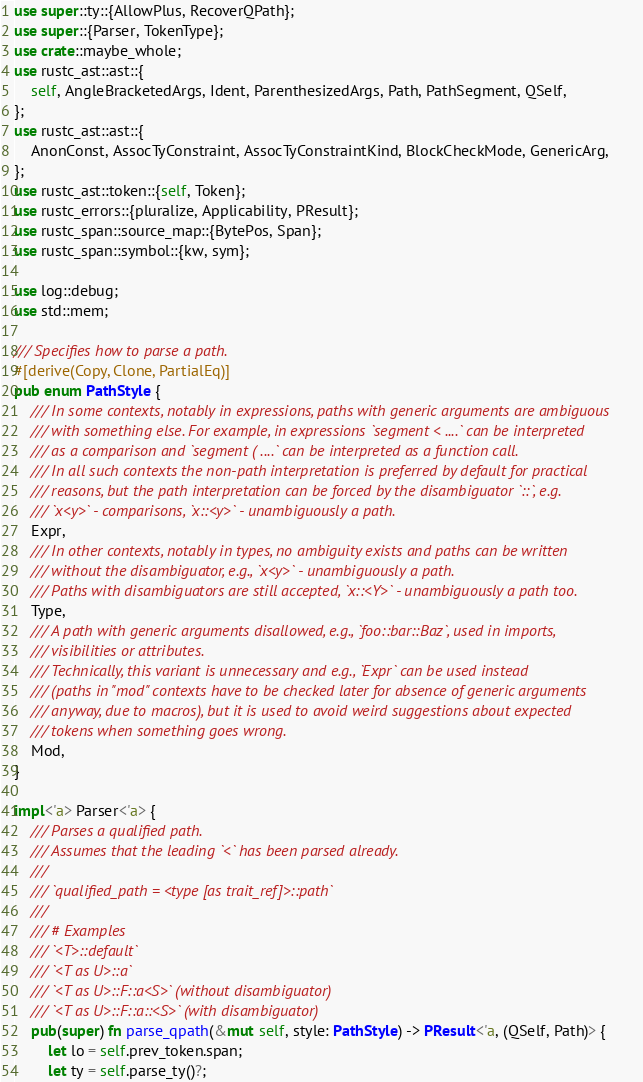<code> <loc_0><loc_0><loc_500><loc_500><_Rust_>use super::ty::{AllowPlus, RecoverQPath};
use super::{Parser, TokenType};
use crate::maybe_whole;
use rustc_ast::ast::{
    self, AngleBracketedArgs, Ident, ParenthesizedArgs, Path, PathSegment, QSelf,
};
use rustc_ast::ast::{
    AnonConst, AssocTyConstraint, AssocTyConstraintKind, BlockCheckMode, GenericArg,
};
use rustc_ast::token::{self, Token};
use rustc_errors::{pluralize, Applicability, PResult};
use rustc_span::source_map::{BytePos, Span};
use rustc_span::symbol::{kw, sym};

use log::debug;
use std::mem;

/// Specifies how to parse a path.
#[derive(Copy, Clone, PartialEq)]
pub enum PathStyle {
    /// In some contexts, notably in expressions, paths with generic arguments are ambiguous
    /// with something else. For example, in expressions `segment < ....` can be interpreted
    /// as a comparison and `segment ( ....` can be interpreted as a function call.
    /// In all such contexts the non-path interpretation is preferred by default for practical
    /// reasons, but the path interpretation can be forced by the disambiguator `::`, e.g.
    /// `x<y>` - comparisons, `x::<y>` - unambiguously a path.
    Expr,
    /// In other contexts, notably in types, no ambiguity exists and paths can be written
    /// without the disambiguator, e.g., `x<y>` - unambiguously a path.
    /// Paths with disambiguators are still accepted, `x::<Y>` - unambiguously a path too.
    Type,
    /// A path with generic arguments disallowed, e.g., `foo::bar::Baz`, used in imports,
    /// visibilities or attributes.
    /// Technically, this variant is unnecessary and e.g., `Expr` can be used instead
    /// (paths in "mod" contexts have to be checked later for absence of generic arguments
    /// anyway, due to macros), but it is used to avoid weird suggestions about expected
    /// tokens when something goes wrong.
    Mod,
}

impl<'a> Parser<'a> {
    /// Parses a qualified path.
    /// Assumes that the leading `<` has been parsed already.
    ///
    /// `qualified_path = <type [as trait_ref]>::path`
    ///
    /// # Examples
    /// `<T>::default`
    /// `<T as U>::a`
    /// `<T as U>::F::a<S>` (without disambiguator)
    /// `<T as U>::F::a::<S>` (with disambiguator)
    pub(super) fn parse_qpath(&mut self, style: PathStyle) -> PResult<'a, (QSelf, Path)> {
        let lo = self.prev_token.span;
        let ty = self.parse_ty()?;
</code> 